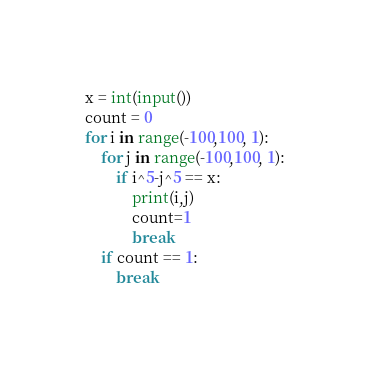<code> <loc_0><loc_0><loc_500><loc_500><_Python_>x = int(input())
count = 0
for i in range(-100,100, 1):
    for j in range(-100,100, 1):
        if i^5-j^5 == x:
            print(i,j)
            count=1
            break
    if count == 1:
        break</code> 